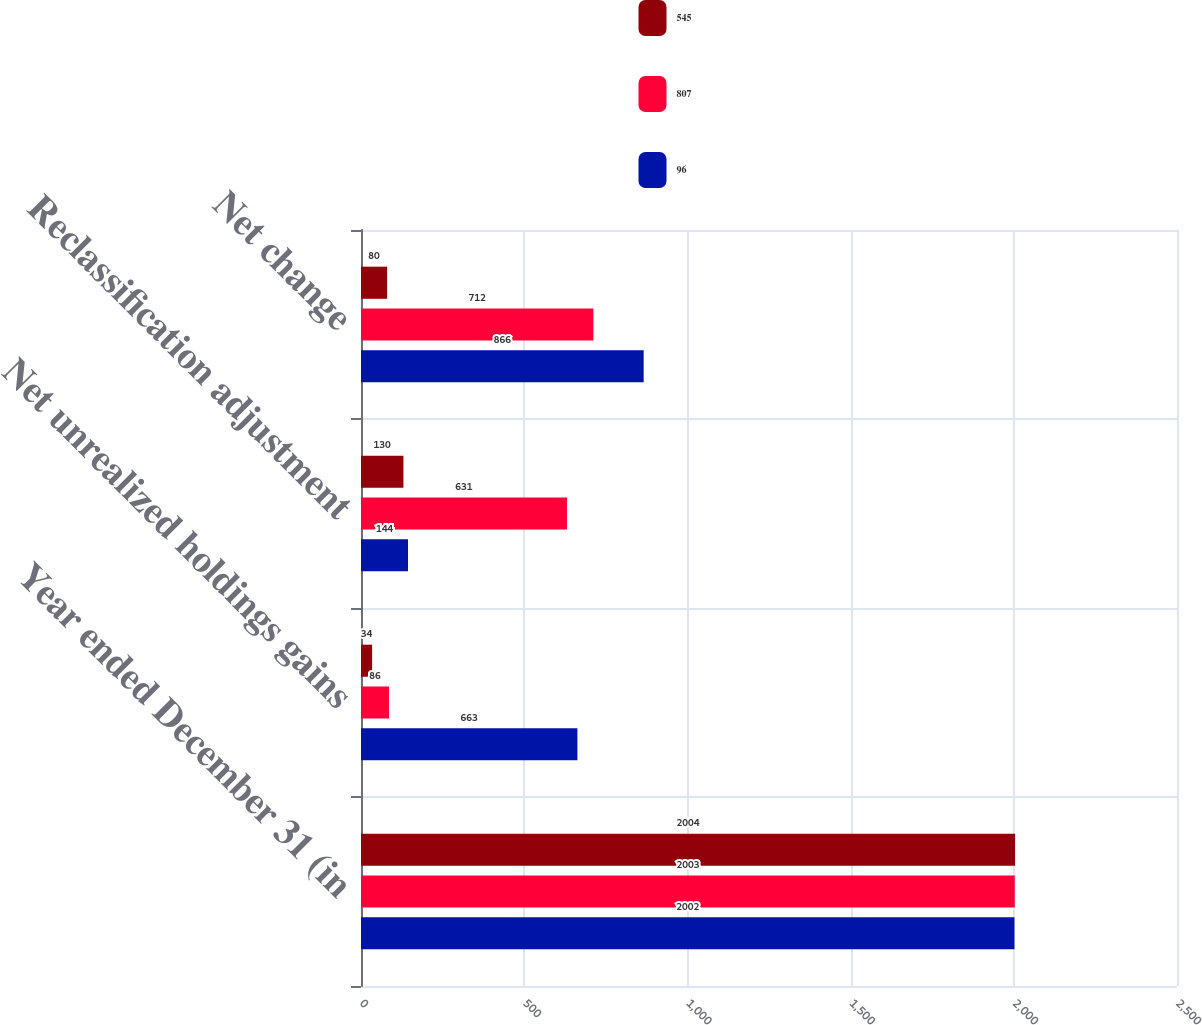Convert chart to OTSL. <chart><loc_0><loc_0><loc_500><loc_500><stacked_bar_chart><ecel><fcel>Year ended December 31 (in<fcel>Net unrealized holdings gains<fcel>Reclassification adjustment<fcel>Net change<nl><fcel>545<fcel>2004<fcel>34<fcel>130<fcel>80<nl><fcel>807<fcel>2003<fcel>86<fcel>631<fcel>712<nl><fcel>96<fcel>2002<fcel>663<fcel>144<fcel>866<nl></chart> 